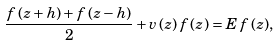<formula> <loc_0><loc_0><loc_500><loc_500>\frac { f \, ( z + h ) + f \, ( z - h ) } 2 + v \, ( z ) \, f \, ( z ) = E \, f \, ( z ) ,</formula> 